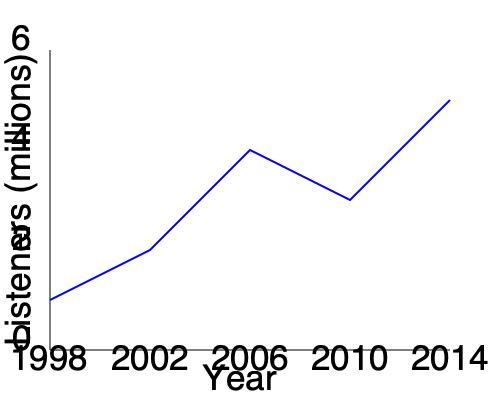Analyzing the line graph depicting Home Truths listener demographics from 1998 to 2014, what was the approximate percentage increase in listeners between 1998 and 2014? To calculate the percentage increase in listeners between 1998 and 2014, we need to follow these steps:

1. Determine the number of listeners in 1998 (start point):
   The graph shows approximately 1 million listeners in 1998.

2. Determine the number of listeners in 2014 (end point):
   The graph shows approximately 5 million listeners in 2014.

3. Calculate the absolute increase:
   $5 \text{ million} - 1 \text{ million} = 4 \text{ million}$

4. Calculate the percentage increase:
   Percentage increase = $\frac{\text{Increase}}{\text{Original Value}} \times 100\%$
   
   $= \frac{4 \text{ million}}{1 \text{ million}} \times 100\%$
   
   $= 4 \times 100\%$
   
   $= 400\%$

Therefore, the percentage increase in Home Truths listeners between 1998 and 2014 was approximately 400%.
Answer: 400% 